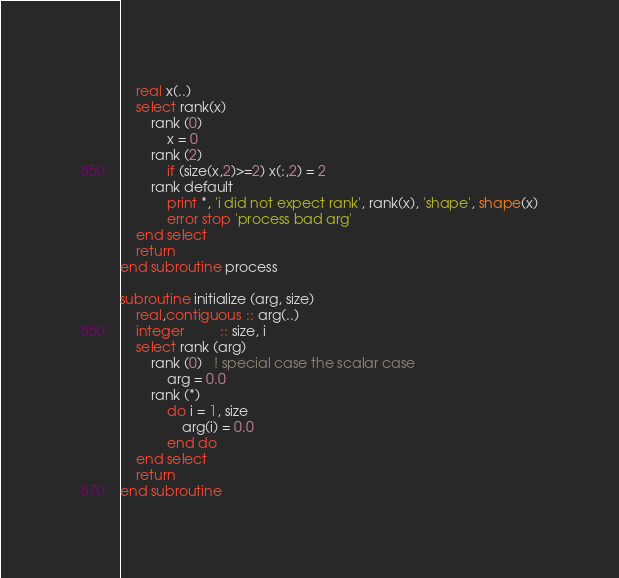<code> <loc_0><loc_0><loc_500><loc_500><_FORTRAN_>    real x(..)
    select rank(x)
        rank (0)
            x = 0
        rank (2)
            if (size(x,2)>=2) x(:,2) = 2
        rank default
            print *, 'i did not expect rank', rank(x), 'shape', shape(x)
            error stop 'process bad arg'
    end select
    return
end subroutine process

subroutine initialize (arg, size)
    real,contiguous :: arg(..)
    integer         :: size, i
    select rank (arg)
        rank (0)   ! special case the scalar case
            arg = 0.0
        rank (*)
            do i = 1, size
                arg(i) = 0.0
            end do
    end select
    return
end subroutine
</code> 